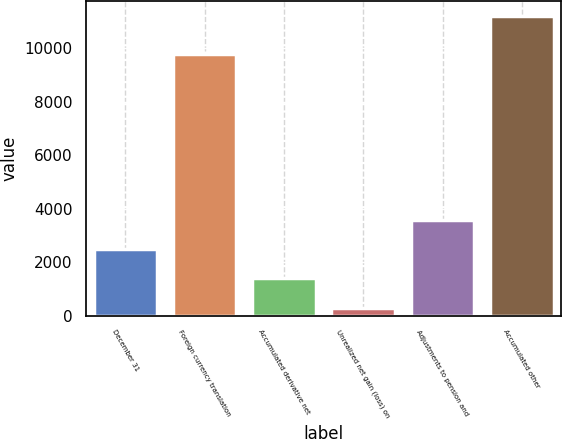<chart> <loc_0><loc_0><loc_500><loc_500><bar_chart><fcel>December 31<fcel>Foreign currency translation<fcel>Accumulated derivative net<fcel>Unrealized net gain (loss) on<fcel>Adjustments to pension and<fcel>Accumulated other<nl><fcel>2485<fcel>9780<fcel>1395<fcel>305<fcel>3575<fcel>11205<nl></chart> 